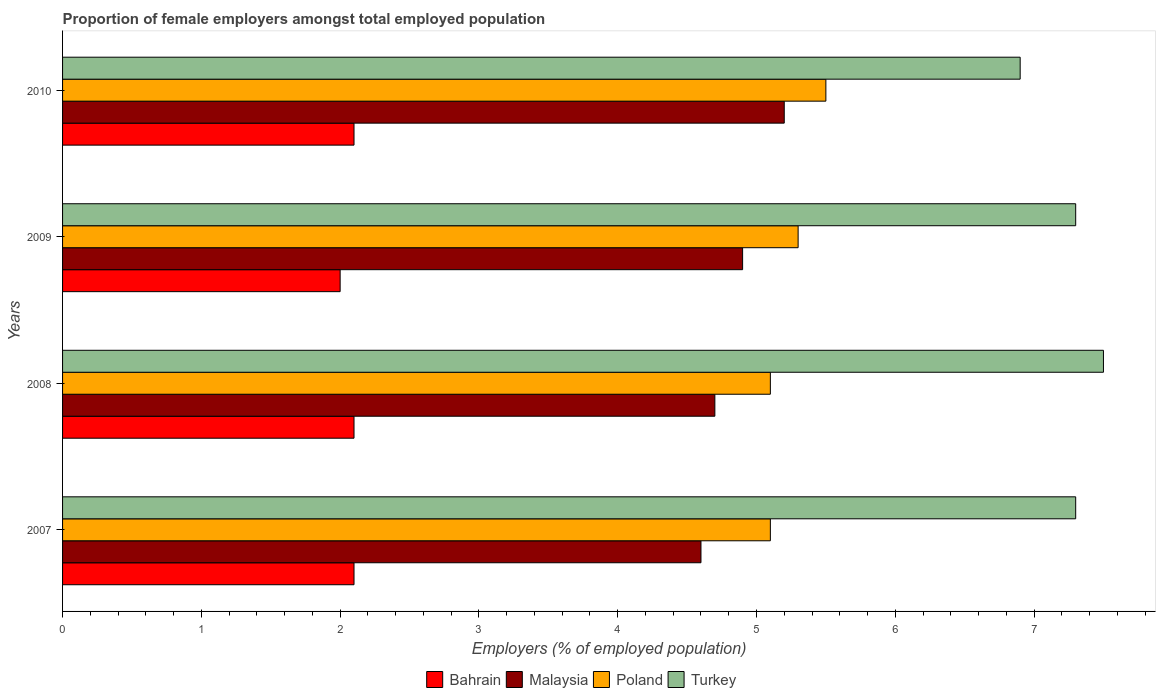How many groups of bars are there?
Your response must be concise. 4. Are the number of bars on each tick of the Y-axis equal?
Provide a succinct answer. Yes. What is the label of the 3rd group of bars from the top?
Ensure brevity in your answer.  2008. What is the proportion of female employers in Malaysia in 2009?
Give a very brief answer. 4.9. What is the total proportion of female employers in Poland in the graph?
Your answer should be compact. 21. What is the difference between the proportion of female employers in Bahrain in 2010 and the proportion of female employers in Malaysia in 2008?
Offer a very short reply. -2.6. What is the average proportion of female employers in Poland per year?
Your response must be concise. 5.25. In the year 2009, what is the difference between the proportion of female employers in Malaysia and proportion of female employers in Bahrain?
Offer a very short reply. 2.9. In how many years, is the proportion of female employers in Bahrain greater than 3.8 %?
Offer a terse response. 0. What is the ratio of the proportion of female employers in Malaysia in 2007 to that in 2010?
Keep it short and to the point. 0.88. What is the difference between the highest and the second highest proportion of female employers in Malaysia?
Offer a very short reply. 0.3. What is the difference between the highest and the lowest proportion of female employers in Bahrain?
Offer a very short reply. 0.1. Is the sum of the proportion of female employers in Turkey in 2007 and 2009 greater than the maximum proportion of female employers in Bahrain across all years?
Provide a succinct answer. Yes. Is it the case that in every year, the sum of the proportion of female employers in Poland and proportion of female employers in Malaysia is greater than the sum of proportion of female employers in Turkey and proportion of female employers in Bahrain?
Make the answer very short. Yes. What does the 4th bar from the top in 2009 represents?
Your answer should be compact. Bahrain. Is it the case that in every year, the sum of the proportion of female employers in Malaysia and proportion of female employers in Poland is greater than the proportion of female employers in Bahrain?
Ensure brevity in your answer.  Yes. Are all the bars in the graph horizontal?
Give a very brief answer. Yes. How many years are there in the graph?
Offer a terse response. 4. What is the difference between two consecutive major ticks on the X-axis?
Make the answer very short. 1. Does the graph contain any zero values?
Provide a succinct answer. No. How many legend labels are there?
Your answer should be very brief. 4. How are the legend labels stacked?
Your answer should be very brief. Horizontal. What is the title of the graph?
Provide a short and direct response. Proportion of female employers amongst total employed population. Does "France" appear as one of the legend labels in the graph?
Provide a short and direct response. No. What is the label or title of the X-axis?
Your answer should be compact. Employers (% of employed population). What is the Employers (% of employed population) of Bahrain in 2007?
Ensure brevity in your answer.  2.1. What is the Employers (% of employed population) in Malaysia in 2007?
Offer a terse response. 4.6. What is the Employers (% of employed population) of Poland in 2007?
Provide a succinct answer. 5.1. What is the Employers (% of employed population) in Turkey in 2007?
Your answer should be compact. 7.3. What is the Employers (% of employed population) of Bahrain in 2008?
Your answer should be very brief. 2.1. What is the Employers (% of employed population) in Malaysia in 2008?
Ensure brevity in your answer.  4.7. What is the Employers (% of employed population) in Poland in 2008?
Keep it short and to the point. 5.1. What is the Employers (% of employed population) of Turkey in 2008?
Keep it short and to the point. 7.5. What is the Employers (% of employed population) of Bahrain in 2009?
Give a very brief answer. 2. What is the Employers (% of employed population) of Malaysia in 2009?
Offer a terse response. 4.9. What is the Employers (% of employed population) in Poland in 2009?
Your answer should be very brief. 5.3. What is the Employers (% of employed population) in Turkey in 2009?
Keep it short and to the point. 7.3. What is the Employers (% of employed population) of Bahrain in 2010?
Keep it short and to the point. 2.1. What is the Employers (% of employed population) in Malaysia in 2010?
Ensure brevity in your answer.  5.2. What is the Employers (% of employed population) in Poland in 2010?
Keep it short and to the point. 5.5. What is the Employers (% of employed population) of Turkey in 2010?
Keep it short and to the point. 6.9. Across all years, what is the maximum Employers (% of employed population) of Bahrain?
Make the answer very short. 2.1. Across all years, what is the maximum Employers (% of employed population) in Malaysia?
Offer a very short reply. 5.2. Across all years, what is the minimum Employers (% of employed population) of Malaysia?
Your response must be concise. 4.6. Across all years, what is the minimum Employers (% of employed population) of Poland?
Keep it short and to the point. 5.1. Across all years, what is the minimum Employers (% of employed population) of Turkey?
Provide a short and direct response. 6.9. What is the total Employers (% of employed population) in Poland in the graph?
Offer a terse response. 21. What is the total Employers (% of employed population) of Turkey in the graph?
Provide a succinct answer. 29. What is the difference between the Employers (% of employed population) in Turkey in 2007 and that in 2008?
Offer a very short reply. -0.2. What is the difference between the Employers (% of employed population) of Bahrain in 2007 and that in 2009?
Offer a terse response. 0.1. What is the difference between the Employers (% of employed population) of Malaysia in 2007 and that in 2009?
Give a very brief answer. -0.3. What is the difference between the Employers (% of employed population) in Turkey in 2007 and that in 2009?
Your response must be concise. 0. What is the difference between the Employers (% of employed population) in Bahrain in 2007 and that in 2010?
Your answer should be very brief. 0. What is the difference between the Employers (% of employed population) of Malaysia in 2007 and that in 2010?
Give a very brief answer. -0.6. What is the difference between the Employers (% of employed population) in Turkey in 2007 and that in 2010?
Give a very brief answer. 0.4. What is the difference between the Employers (% of employed population) in Poland in 2008 and that in 2009?
Make the answer very short. -0.2. What is the difference between the Employers (% of employed population) of Turkey in 2008 and that in 2009?
Your response must be concise. 0.2. What is the difference between the Employers (% of employed population) in Turkey in 2008 and that in 2010?
Give a very brief answer. 0.6. What is the difference between the Employers (% of employed population) of Poland in 2009 and that in 2010?
Keep it short and to the point. -0.2. What is the difference between the Employers (% of employed population) in Turkey in 2009 and that in 2010?
Ensure brevity in your answer.  0.4. What is the difference between the Employers (% of employed population) of Bahrain in 2007 and the Employers (% of employed population) of Malaysia in 2008?
Make the answer very short. -2.6. What is the difference between the Employers (% of employed population) of Malaysia in 2007 and the Employers (% of employed population) of Poland in 2008?
Your answer should be compact. -0.5. What is the difference between the Employers (% of employed population) of Malaysia in 2007 and the Employers (% of employed population) of Turkey in 2008?
Your answer should be compact. -2.9. What is the difference between the Employers (% of employed population) of Bahrain in 2007 and the Employers (% of employed population) of Poland in 2009?
Give a very brief answer. -3.2. What is the difference between the Employers (% of employed population) in Bahrain in 2007 and the Employers (% of employed population) in Turkey in 2009?
Ensure brevity in your answer.  -5.2. What is the difference between the Employers (% of employed population) of Malaysia in 2007 and the Employers (% of employed population) of Poland in 2009?
Provide a short and direct response. -0.7. What is the difference between the Employers (% of employed population) of Malaysia in 2007 and the Employers (% of employed population) of Turkey in 2009?
Offer a terse response. -2.7. What is the difference between the Employers (% of employed population) of Poland in 2007 and the Employers (% of employed population) of Turkey in 2009?
Offer a terse response. -2.2. What is the difference between the Employers (% of employed population) in Bahrain in 2007 and the Employers (% of employed population) in Turkey in 2010?
Your answer should be very brief. -4.8. What is the difference between the Employers (% of employed population) in Malaysia in 2007 and the Employers (% of employed population) in Turkey in 2010?
Offer a terse response. -2.3. What is the difference between the Employers (% of employed population) in Poland in 2007 and the Employers (% of employed population) in Turkey in 2010?
Keep it short and to the point. -1.8. What is the difference between the Employers (% of employed population) in Bahrain in 2008 and the Employers (% of employed population) in Malaysia in 2009?
Keep it short and to the point. -2.8. What is the difference between the Employers (% of employed population) of Bahrain in 2008 and the Employers (% of employed population) of Poland in 2009?
Make the answer very short. -3.2. What is the difference between the Employers (% of employed population) of Bahrain in 2008 and the Employers (% of employed population) of Turkey in 2009?
Provide a succinct answer. -5.2. What is the difference between the Employers (% of employed population) of Malaysia in 2008 and the Employers (% of employed population) of Poland in 2009?
Your answer should be compact. -0.6. What is the difference between the Employers (% of employed population) of Malaysia in 2008 and the Employers (% of employed population) of Turkey in 2009?
Give a very brief answer. -2.6. What is the difference between the Employers (% of employed population) of Poland in 2008 and the Employers (% of employed population) of Turkey in 2009?
Ensure brevity in your answer.  -2.2. What is the difference between the Employers (% of employed population) of Bahrain in 2008 and the Employers (% of employed population) of Poland in 2010?
Offer a very short reply. -3.4. What is the difference between the Employers (% of employed population) in Bahrain in 2008 and the Employers (% of employed population) in Turkey in 2010?
Make the answer very short. -4.8. What is the difference between the Employers (% of employed population) of Malaysia in 2008 and the Employers (% of employed population) of Poland in 2010?
Keep it short and to the point. -0.8. What is the difference between the Employers (% of employed population) in Bahrain in 2009 and the Employers (% of employed population) in Malaysia in 2010?
Offer a very short reply. -3.2. What is the difference between the Employers (% of employed population) in Bahrain in 2009 and the Employers (% of employed population) in Poland in 2010?
Make the answer very short. -3.5. What is the difference between the Employers (% of employed population) of Malaysia in 2009 and the Employers (% of employed population) of Turkey in 2010?
Make the answer very short. -2. What is the average Employers (% of employed population) of Bahrain per year?
Your answer should be compact. 2.08. What is the average Employers (% of employed population) of Malaysia per year?
Provide a short and direct response. 4.85. What is the average Employers (% of employed population) in Poland per year?
Your answer should be very brief. 5.25. What is the average Employers (% of employed population) in Turkey per year?
Your response must be concise. 7.25. In the year 2007, what is the difference between the Employers (% of employed population) of Bahrain and Employers (% of employed population) of Turkey?
Provide a succinct answer. -5.2. In the year 2007, what is the difference between the Employers (% of employed population) in Malaysia and Employers (% of employed population) in Poland?
Offer a terse response. -0.5. In the year 2009, what is the difference between the Employers (% of employed population) of Bahrain and Employers (% of employed population) of Malaysia?
Your response must be concise. -2.9. In the year 2009, what is the difference between the Employers (% of employed population) of Bahrain and Employers (% of employed population) of Poland?
Give a very brief answer. -3.3. In the year 2009, what is the difference between the Employers (% of employed population) in Bahrain and Employers (% of employed population) in Turkey?
Keep it short and to the point. -5.3. In the year 2009, what is the difference between the Employers (% of employed population) in Malaysia and Employers (% of employed population) in Poland?
Your answer should be very brief. -0.4. In the year 2009, what is the difference between the Employers (% of employed population) of Malaysia and Employers (% of employed population) of Turkey?
Give a very brief answer. -2.4. In the year 2009, what is the difference between the Employers (% of employed population) in Poland and Employers (% of employed population) in Turkey?
Your answer should be very brief. -2. In the year 2010, what is the difference between the Employers (% of employed population) in Bahrain and Employers (% of employed population) in Poland?
Offer a very short reply. -3.4. In the year 2010, what is the difference between the Employers (% of employed population) of Bahrain and Employers (% of employed population) of Turkey?
Your answer should be very brief. -4.8. In the year 2010, what is the difference between the Employers (% of employed population) of Poland and Employers (% of employed population) of Turkey?
Make the answer very short. -1.4. What is the ratio of the Employers (% of employed population) in Malaysia in 2007 to that in 2008?
Provide a short and direct response. 0.98. What is the ratio of the Employers (% of employed population) in Turkey in 2007 to that in 2008?
Provide a succinct answer. 0.97. What is the ratio of the Employers (% of employed population) in Bahrain in 2007 to that in 2009?
Offer a terse response. 1.05. What is the ratio of the Employers (% of employed population) of Malaysia in 2007 to that in 2009?
Provide a short and direct response. 0.94. What is the ratio of the Employers (% of employed population) of Poland in 2007 to that in 2009?
Your response must be concise. 0.96. What is the ratio of the Employers (% of employed population) in Turkey in 2007 to that in 2009?
Provide a succinct answer. 1. What is the ratio of the Employers (% of employed population) in Malaysia in 2007 to that in 2010?
Your answer should be compact. 0.88. What is the ratio of the Employers (% of employed population) in Poland in 2007 to that in 2010?
Provide a short and direct response. 0.93. What is the ratio of the Employers (% of employed population) in Turkey in 2007 to that in 2010?
Provide a short and direct response. 1.06. What is the ratio of the Employers (% of employed population) of Bahrain in 2008 to that in 2009?
Your response must be concise. 1.05. What is the ratio of the Employers (% of employed population) in Malaysia in 2008 to that in 2009?
Offer a very short reply. 0.96. What is the ratio of the Employers (% of employed population) in Poland in 2008 to that in 2009?
Make the answer very short. 0.96. What is the ratio of the Employers (% of employed population) of Turkey in 2008 to that in 2009?
Provide a succinct answer. 1.03. What is the ratio of the Employers (% of employed population) in Bahrain in 2008 to that in 2010?
Make the answer very short. 1. What is the ratio of the Employers (% of employed population) of Malaysia in 2008 to that in 2010?
Your answer should be very brief. 0.9. What is the ratio of the Employers (% of employed population) in Poland in 2008 to that in 2010?
Your response must be concise. 0.93. What is the ratio of the Employers (% of employed population) in Turkey in 2008 to that in 2010?
Keep it short and to the point. 1.09. What is the ratio of the Employers (% of employed population) in Malaysia in 2009 to that in 2010?
Your answer should be compact. 0.94. What is the ratio of the Employers (% of employed population) in Poland in 2009 to that in 2010?
Provide a short and direct response. 0.96. What is the ratio of the Employers (% of employed population) in Turkey in 2009 to that in 2010?
Give a very brief answer. 1.06. What is the difference between the highest and the second highest Employers (% of employed population) of Bahrain?
Offer a terse response. 0. What is the difference between the highest and the second highest Employers (% of employed population) in Malaysia?
Ensure brevity in your answer.  0.3. What is the difference between the highest and the lowest Employers (% of employed population) of Malaysia?
Offer a terse response. 0.6. What is the difference between the highest and the lowest Employers (% of employed population) in Turkey?
Your response must be concise. 0.6. 